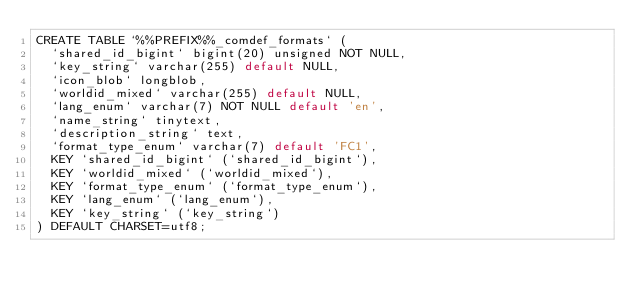Convert code to text. <code><loc_0><loc_0><loc_500><loc_500><_SQL_>CREATE TABLE `%%PREFIX%%_comdef_formats` (
  `shared_id_bigint` bigint(20) unsigned NOT NULL,
  `key_string` varchar(255) default NULL,
  `icon_blob` longblob,
  `worldid_mixed` varchar(255) default NULL,
  `lang_enum` varchar(7) NOT NULL default 'en',
  `name_string` tinytext,
  `description_string` text,
  `format_type_enum` varchar(7) default 'FC1',
  KEY `shared_id_bigint` (`shared_id_bigint`),
  KEY `worldid_mixed` (`worldid_mixed`),
  KEY `format_type_enum` (`format_type_enum`),
  KEY `lang_enum` (`lang_enum`),
  KEY `key_string` (`key_string`)
) DEFAULT CHARSET=utf8;
</code> 